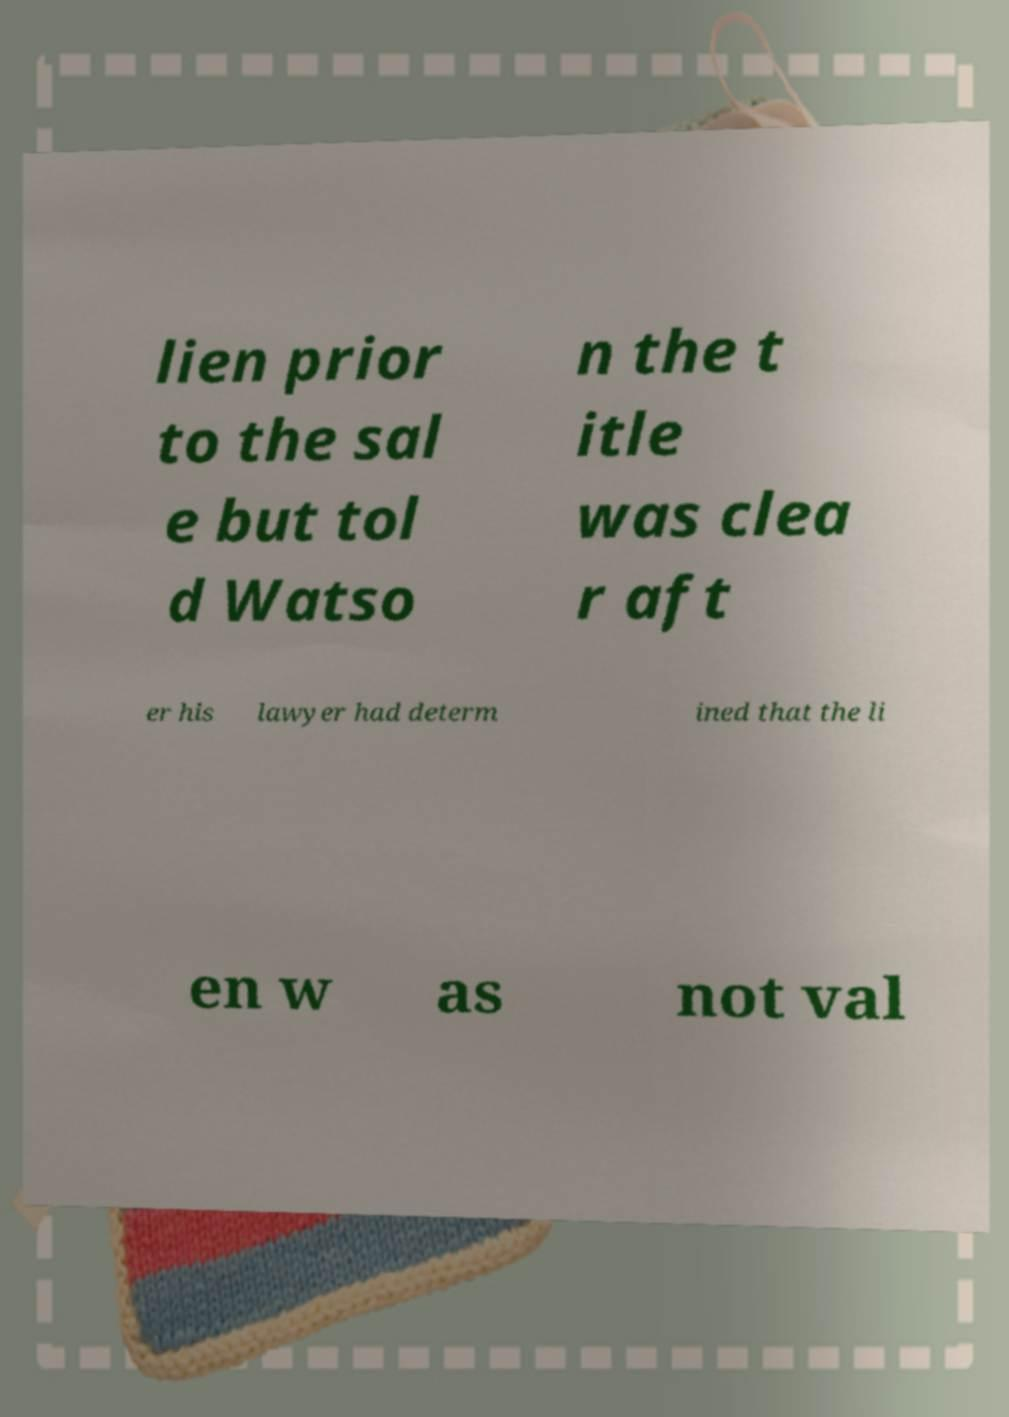What messages or text are displayed in this image? I need them in a readable, typed format. lien prior to the sal e but tol d Watso n the t itle was clea r aft er his lawyer had determ ined that the li en w as not val 